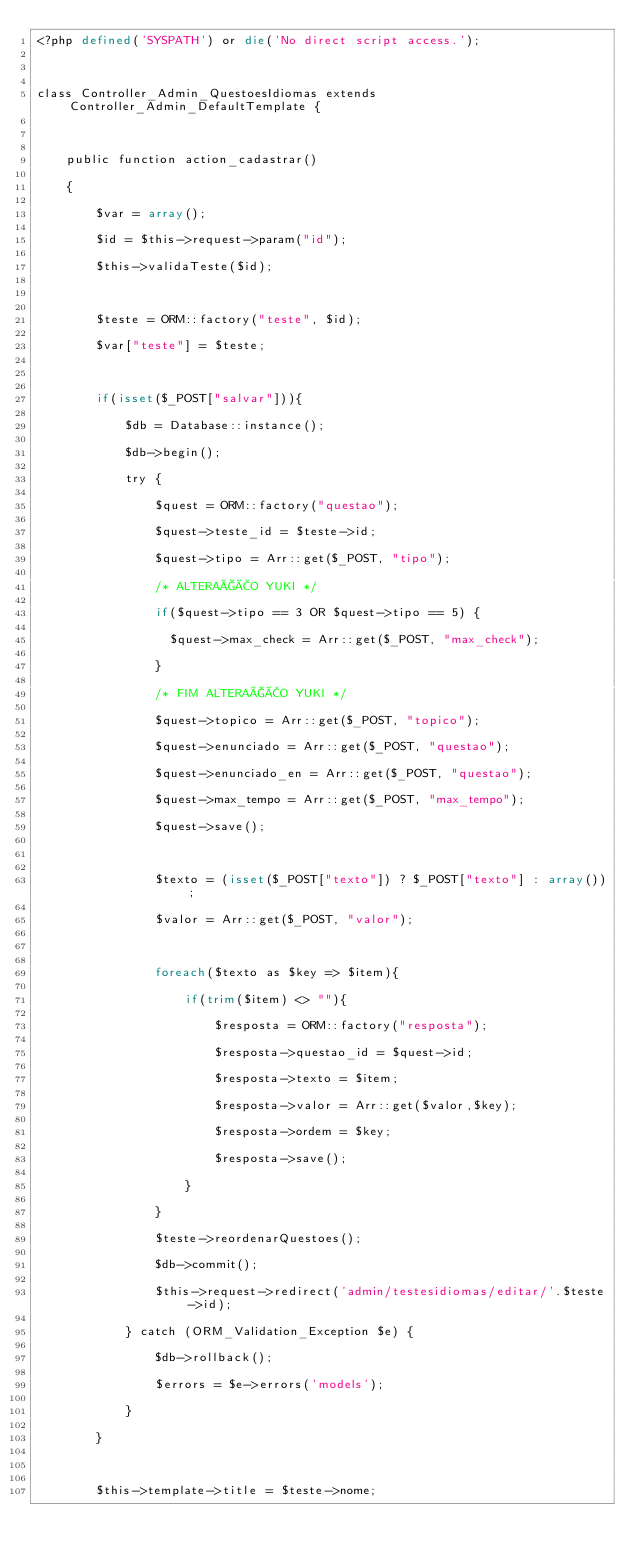<code> <loc_0><loc_0><loc_500><loc_500><_PHP_><?php defined('SYSPATH') or die('No direct script access.');

class Controller_Admin_QuestoesIdiomas extends Controller_Admin_DefaultTemplate {

	public function action_cadastrar()
	{
		$var = array();
		$id = $this->request->param("id");
		$this->validaTeste($id);

		$teste = ORM::factory("teste", $id);
		$var["teste"] = $teste;

		if(isset($_POST["salvar"])){
			$db = Database::instance();
			$db->begin();
			try {
				$quest = ORM::factory("questao");
				$quest->teste_id = $teste->id;
				$quest->tipo = Arr::get($_POST, "tipo");
				/* ALTERAÇÃO YUKI */
				if($quest->tipo == 3 OR $quest->tipo == 5) {
				  $quest->max_check = Arr::get($_POST, "max_check");
				}
				/* FIM ALTERAÇÃO YUKI */
				$quest->topico = Arr::get($_POST, "topico");
				$quest->enunciado = Arr::get($_POST, "questao");
				$quest->enunciado_en = Arr::get($_POST, "questao");
				$quest->max_tempo = Arr::get($_POST, "max_tempo");
				$quest->save();

				$texto = (isset($_POST["texto"]) ? $_POST["texto"] : array());
				$valor = Arr::get($_POST, "valor");

				foreach($texto as $key => $item){
					if(trim($item) <> ""){
						$resposta = ORM::factory("resposta");
						$resposta->questao_id = $quest->id;
						$resposta->texto = $item;
						$resposta->valor = Arr::get($valor,$key);
						$resposta->ordem = $key;
						$resposta->save();
					}
				}
				$teste->reordenarQuestoes();
				$db->commit();
				$this->request->redirect('admin/testesidiomas/editar/'.$teste->id);
			} catch (ORM_Validation_Exception $e) {
				$db->rollback();
				$errors = $e->errors('models');
			}
		}

		$this->template->title = $teste->nome;</code> 